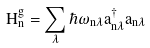<formula> <loc_0><loc_0><loc_500><loc_500>H ^ { g } _ { n } = \sum _ { \lambda } \hbar { \omega } _ { n \lambda } a ^ { \dagger } _ { n \lambda } a _ { n \lambda }</formula> 